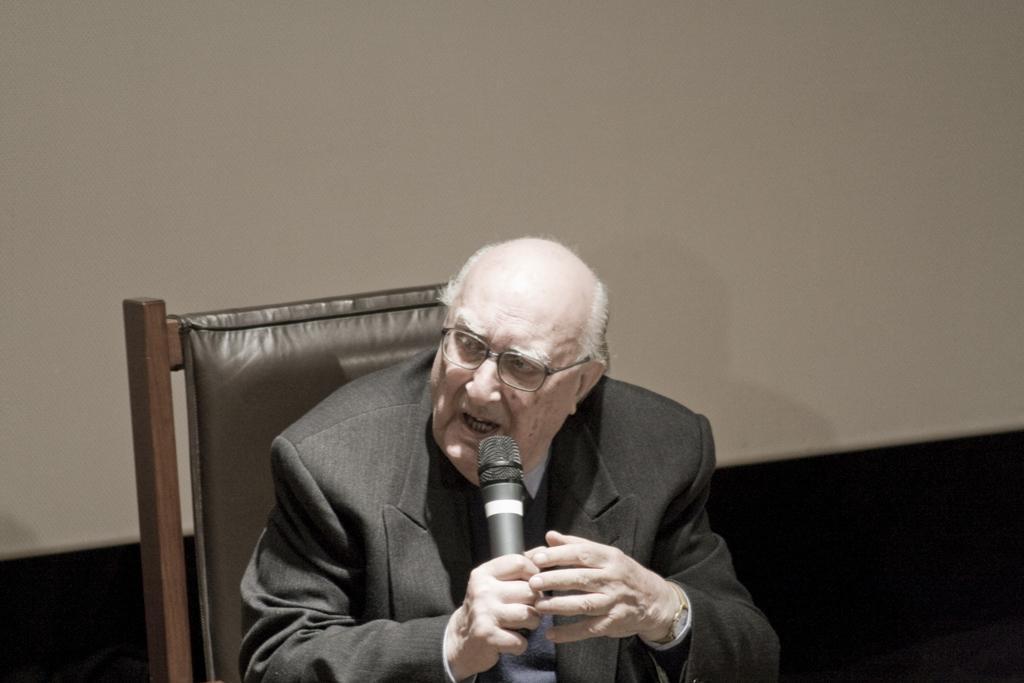Describe this image in one or two sentences. In this picture we can see a person sitting on a chair, he is holding a mic and we can see a wall in the background. 